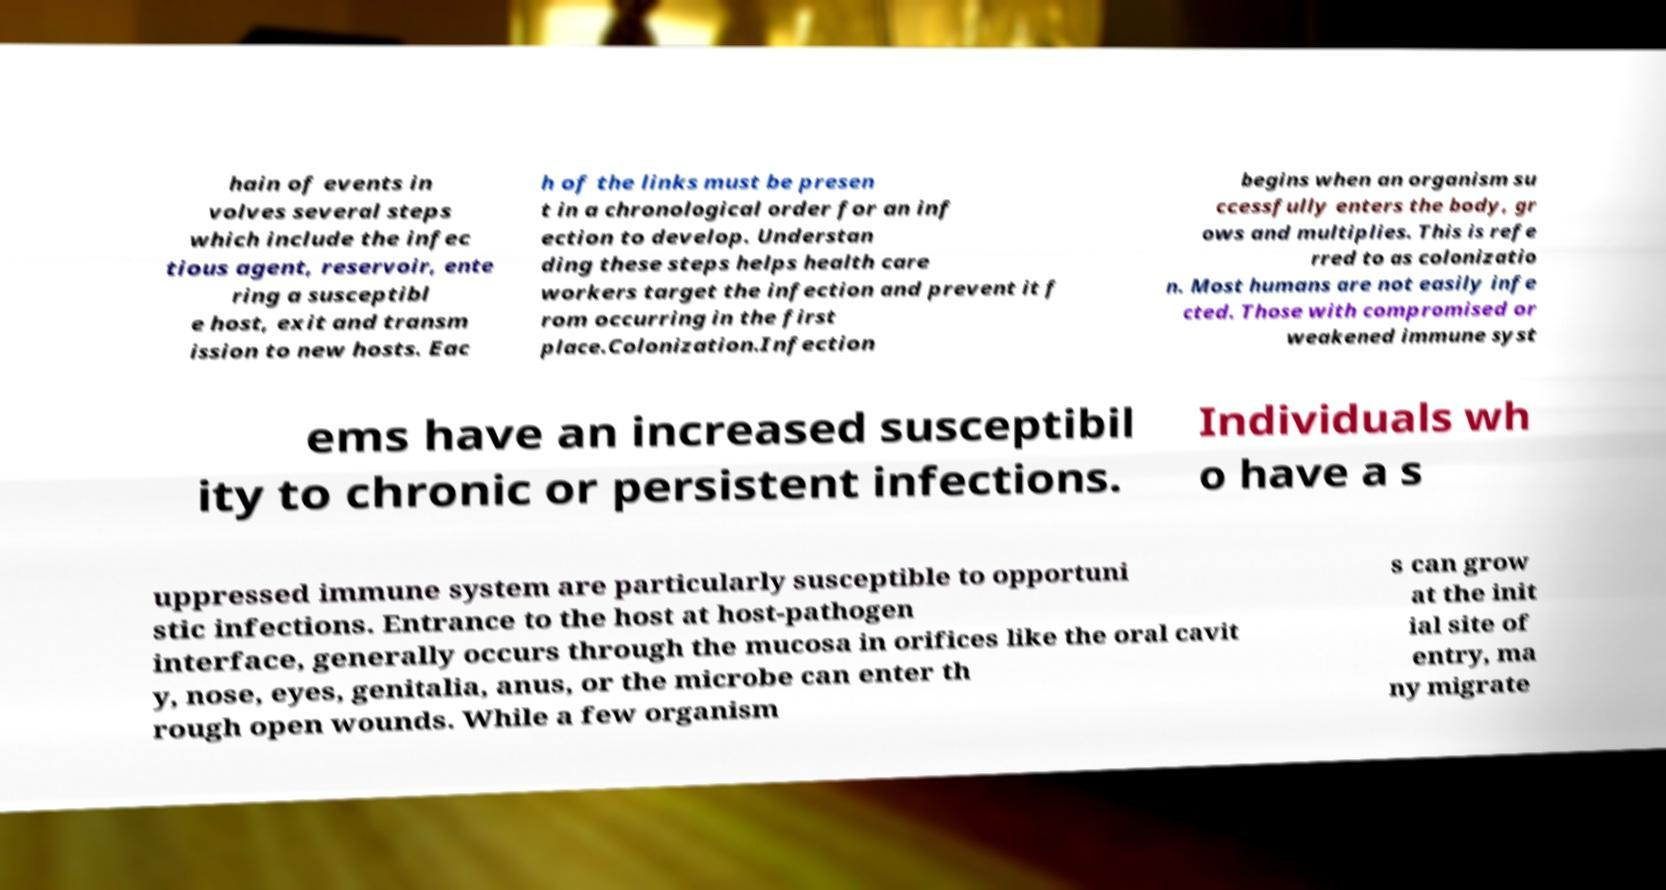There's text embedded in this image that I need extracted. Can you transcribe it verbatim? hain of events in volves several steps which include the infec tious agent, reservoir, ente ring a susceptibl e host, exit and transm ission to new hosts. Eac h of the links must be presen t in a chronological order for an inf ection to develop. Understan ding these steps helps health care workers target the infection and prevent it f rom occurring in the first place.Colonization.Infection begins when an organism su ccessfully enters the body, gr ows and multiplies. This is refe rred to as colonizatio n. Most humans are not easily infe cted. Those with compromised or weakened immune syst ems have an increased susceptibil ity to chronic or persistent infections. Individuals wh o have a s uppressed immune system are particularly susceptible to opportuni stic infections. Entrance to the host at host-pathogen interface, generally occurs through the mucosa in orifices like the oral cavit y, nose, eyes, genitalia, anus, or the microbe can enter th rough open wounds. While a few organism s can grow at the init ial site of entry, ma ny migrate 